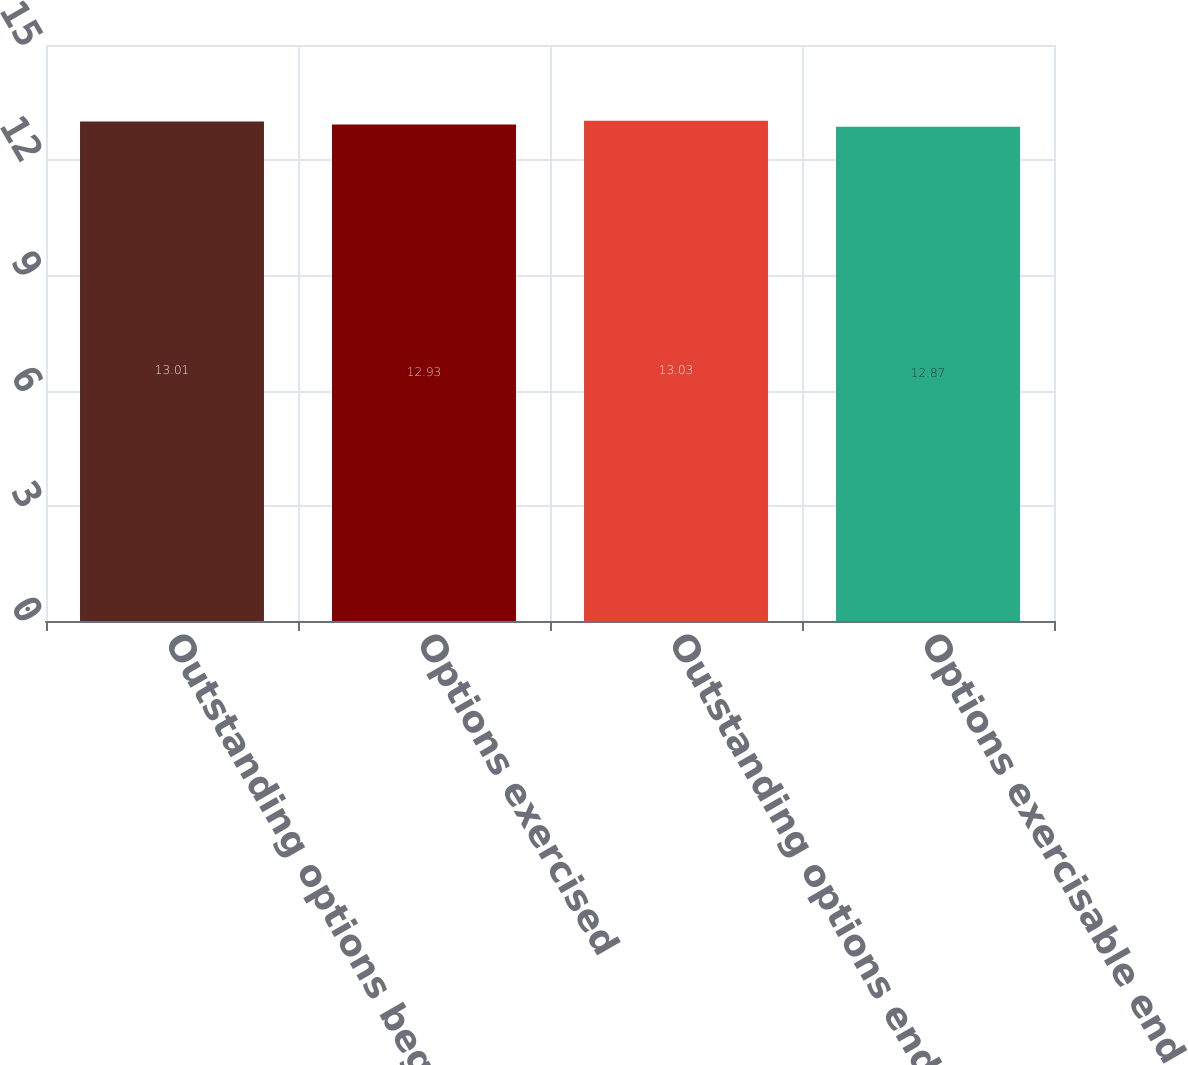<chart> <loc_0><loc_0><loc_500><loc_500><bar_chart><fcel>Outstanding options beginning<fcel>Options exercised<fcel>Outstanding options end of<fcel>Options exercisable end of<nl><fcel>13.01<fcel>12.93<fcel>13.03<fcel>12.87<nl></chart> 